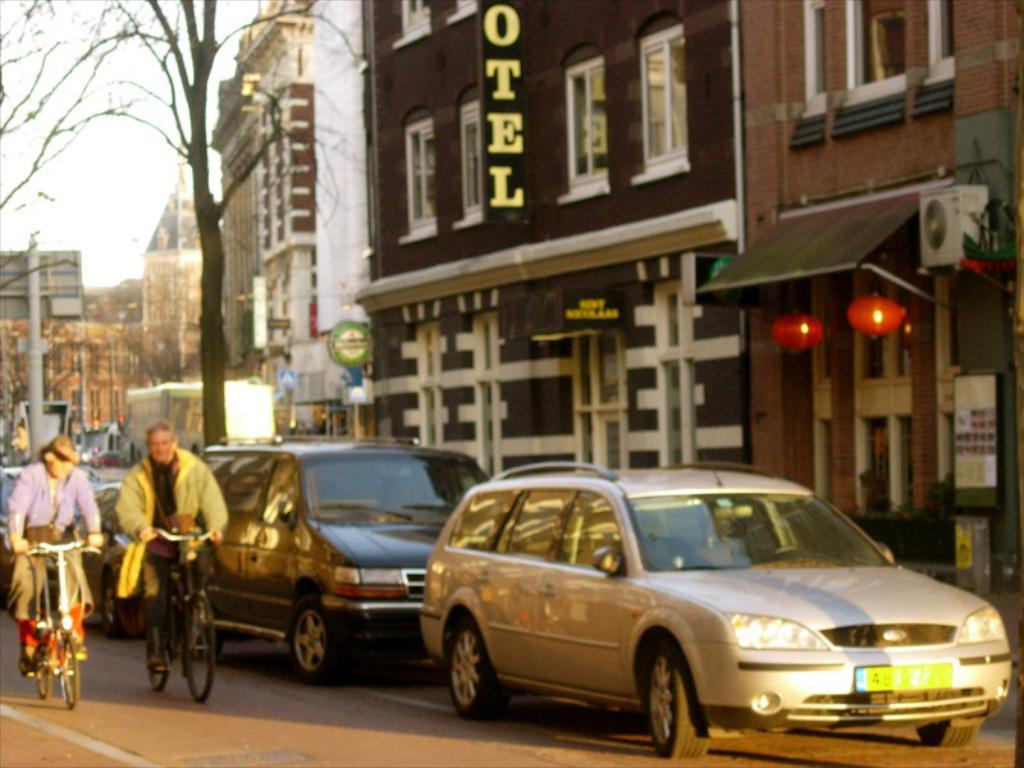Provide a one-sentence caption for the provided image. Two people cycle passed a parked car in the street with a yellow license plate beginning with the number 4. 